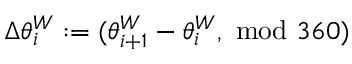Convert formula to latex. <formula><loc_0><loc_0><loc_500><loc_500>\Delta \theta _ { i } ^ { W } \colon = ( \theta _ { i + 1 } ^ { W } - \theta _ { i } ^ { W } , \ m o d \ 3 6 0 )</formula> 